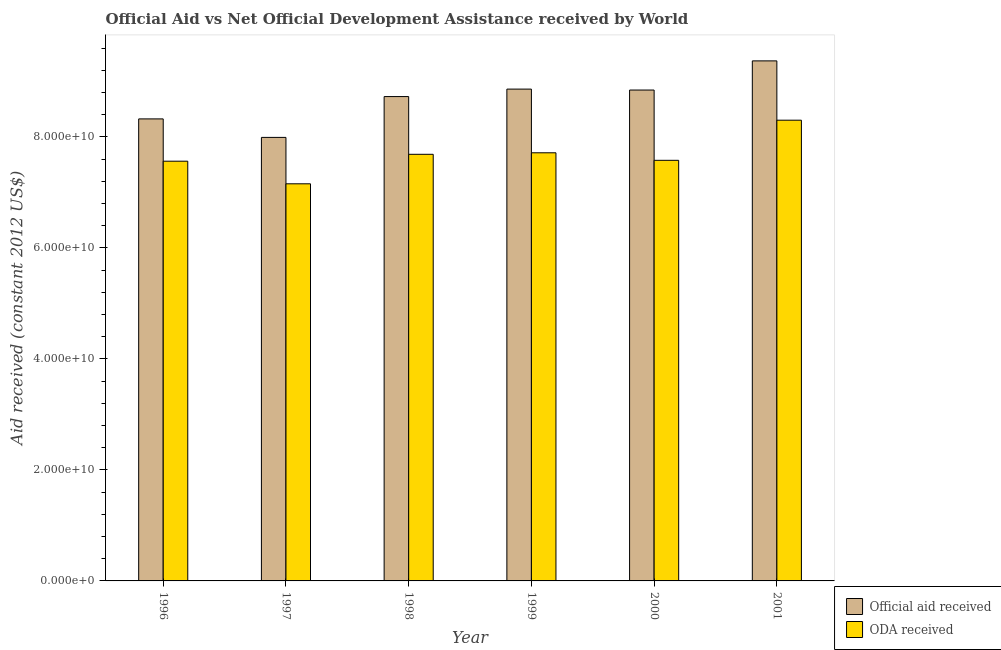How many different coloured bars are there?
Give a very brief answer. 2. Are the number of bars per tick equal to the number of legend labels?
Your answer should be very brief. Yes. How many bars are there on the 3rd tick from the left?
Provide a short and direct response. 2. What is the label of the 2nd group of bars from the left?
Offer a very short reply. 1997. What is the oda received in 1999?
Keep it short and to the point. 7.71e+1. Across all years, what is the maximum official aid received?
Ensure brevity in your answer.  9.37e+1. Across all years, what is the minimum official aid received?
Offer a terse response. 7.99e+1. In which year was the official aid received maximum?
Give a very brief answer. 2001. What is the total official aid received in the graph?
Your response must be concise. 5.21e+11. What is the difference between the official aid received in 1997 and that in 1999?
Offer a very short reply. -8.70e+09. What is the difference between the oda received in 1997 and the official aid received in 1996?
Your response must be concise. -4.07e+09. What is the average oda received per year?
Your answer should be very brief. 7.67e+1. What is the ratio of the official aid received in 1998 to that in 2000?
Provide a short and direct response. 0.99. Is the difference between the oda received in 1998 and 1999 greater than the difference between the official aid received in 1998 and 1999?
Ensure brevity in your answer.  No. What is the difference between the highest and the second highest oda received?
Your answer should be very brief. 5.87e+09. What is the difference between the highest and the lowest oda received?
Offer a very short reply. 1.15e+1. In how many years, is the official aid received greater than the average official aid received taken over all years?
Make the answer very short. 4. What does the 2nd bar from the left in 2000 represents?
Your answer should be compact. ODA received. What does the 2nd bar from the right in 2000 represents?
Your answer should be compact. Official aid received. What is the difference between two consecutive major ticks on the Y-axis?
Give a very brief answer. 2.00e+1. Does the graph contain any zero values?
Give a very brief answer. No. Does the graph contain grids?
Offer a terse response. No. How are the legend labels stacked?
Ensure brevity in your answer.  Vertical. What is the title of the graph?
Your answer should be very brief. Official Aid vs Net Official Development Assistance received by World . What is the label or title of the X-axis?
Your response must be concise. Year. What is the label or title of the Y-axis?
Your answer should be very brief. Aid received (constant 2012 US$). What is the Aid received (constant 2012 US$) in Official aid received in 1996?
Provide a succinct answer. 8.32e+1. What is the Aid received (constant 2012 US$) in ODA received in 1996?
Your answer should be compact. 7.56e+1. What is the Aid received (constant 2012 US$) of Official aid received in 1997?
Offer a very short reply. 7.99e+1. What is the Aid received (constant 2012 US$) in ODA received in 1997?
Your answer should be very brief. 7.15e+1. What is the Aid received (constant 2012 US$) in Official aid received in 1998?
Give a very brief answer. 8.73e+1. What is the Aid received (constant 2012 US$) of ODA received in 1998?
Ensure brevity in your answer.  7.69e+1. What is the Aid received (constant 2012 US$) in Official aid received in 1999?
Offer a very short reply. 8.86e+1. What is the Aid received (constant 2012 US$) in ODA received in 1999?
Your answer should be very brief. 7.71e+1. What is the Aid received (constant 2012 US$) in Official aid received in 2000?
Give a very brief answer. 8.84e+1. What is the Aid received (constant 2012 US$) of ODA received in 2000?
Keep it short and to the point. 7.58e+1. What is the Aid received (constant 2012 US$) in Official aid received in 2001?
Your answer should be compact. 9.37e+1. What is the Aid received (constant 2012 US$) of ODA received in 2001?
Your answer should be very brief. 8.30e+1. Across all years, what is the maximum Aid received (constant 2012 US$) of Official aid received?
Give a very brief answer. 9.37e+1. Across all years, what is the maximum Aid received (constant 2012 US$) of ODA received?
Keep it short and to the point. 8.30e+1. Across all years, what is the minimum Aid received (constant 2012 US$) of Official aid received?
Offer a terse response. 7.99e+1. Across all years, what is the minimum Aid received (constant 2012 US$) in ODA received?
Offer a very short reply. 7.15e+1. What is the total Aid received (constant 2012 US$) of Official aid received in the graph?
Provide a succinct answer. 5.21e+11. What is the total Aid received (constant 2012 US$) in ODA received in the graph?
Ensure brevity in your answer.  4.60e+11. What is the difference between the Aid received (constant 2012 US$) of Official aid received in 1996 and that in 1997?
Ensure brevity in your answer.  3.33e+09. What is the difference between the Aid received (constant 2012 US$) in ODA received in 1996 and that in 1997?
Make the answer very short. 4.07e+09. What is the difference between the Aid received (constant 2012 US$) of Official aid received in 1996 and that in 1998?
Your answer should be compact. -4.02e+09. What is the difference between the Aid received (constant 2012 US$) of ODA received in 1996 and that in 1998?
Your answer should be compact. -1.24e+09. What is the difference between the Aid received (constant 2012 US$) of Official aid received in 1996 and that in 1999?
Your response must be concise. -5.37e+09. What is the difference between the Aid received (constant 2012 US$) in ODA received in 1996 and that in 1999?
Provide a short and direct response. -1.51e+09. What is the difference between the Aid received (constant 2012 US$) in Official aid received in 1996 and that in 2000?
Keep it short and to the point. -5.20e+09. What is the difference between the Aid received (constant 2012 US$) of ODA received in 1996 and that in 2000?
Offer a very short reply. -1.57e+08. What is the difference between the Aid received (constant 2012 US$) in Official aid received in 1996 and that in 2001?
Make the answer very short. -1.05e+1. What is the difference between the Aid received (constant 2012 US$) in ODA received in 1996 and that in 2001?
Give a very brief answer. -7.39e+09. What is the difference between the Aid received (constant 2012 US$) in Official aid received in 1997 and that in 1998?
Make the answer very short. -7.35e+09. What is the difference between the Aid received (constant 2012 US$) of ODA received in 1997 and that in 1998?
Give a very brief answer. -5.31e+09. What is the difference between the Aid received (constant 2012 US$) in Official aid received in 1997 and that in 1999?
Your answer should be very brief. -8.70e+09. What is the difference between the Aid received (constant 2012 US$) of ODA received in 1997 and that in 1999?
Your answer should be very brief. -5.59e+09. What is the difference between the Aid received (constant 2012 US$) of Official aid received in 1997 and that in 2000?
Keep it short and to the point. -8.53e+09. What is the difference between the Aid received (constant 2012 US$) in ODA received in 1997 and that in 2000?
Offer a very short reply. -4.23e+09. What is the difference between the Aid received (constant 2012 US$) in Official aid received in 1997 and that in 2001?
Offer a terse response. -1.38e+1. What is the difference between the Aid received (constant 2012 US$) in ODA received in 1997 and that in 2001?
Keep it short and to the point. -1.15e+1. What is the difference between the Aid received (constant 2012 US$) of Official aid received in 1998 and that in 1999?
Give a very brief answer. -1.35e+09. What is the difference between the Aid received (constant 2012 US$) in ODA received in 1998 and that in 1999?
Your answer should be very brief. -2.73e+08. What is the difference between the Aid received (constant 2012 US$) of Official aid received in 1998 and that in 2000?
Provide a short and direct response. -1.18e+09. What is the difference between the Aid received (constant 2012 US$) in ODA received in 1998 and that in 2000?
Your answer should be compact. 1.08e+09. What is the difference between the Aid received (constant 2012 US$) in Official aid received in 1998 and that in 2001?
Your answer should be compact. -6.43e+09. What is the difference between the Aid received (constant 2012 US$) in ODA received in 1998 and that in 2001?
Make the answer very short. -6.15e+09. What is the difference between the Aid received (constant 2012 US$) in Official aid received in 1999 and that in 2000?
Your answer should be very brief. 1.71e+08. What is the difference between the Aid received (constant 2012 US$) in ODA received in 1999 and that in 2000?
Offer a terse response. 1.36e+09. What is the difference between the Aid received (constant 2012 US$) of Official aid received in 1999 and that in 2001?
Your answer should be compact. -5.08e+09. What is the difference between the Aid received (constant 2012 US$) of ODA received in 1999 and that in 2001?
Ensure brevity in your answer.  -5.87e+09. What is the difference between the Aid received (constant 2012 US$) in Official aid received in 2000 and that in 2001?
Offer a very short reply. -5.25e+09. What is the difference between the Aid received (constant 2012 US$) in ODA received in 2000 and that in 2001?
Provide a succinct answer. -7.23e+09. What is the difference between the Aid received (constant 2012 US$) of Official aid received in 1996 and the Aid received (constant 2012 US$) of ODA received in 1997?
Your answer should be very brief. 1.17e+1. What is the difference between the Aid received (constant 2012 US$) in Official aid received in 1996 and the Aid received (constant 2012 US$) in ODA received in 1998?
Provide a succinct answer. 6.38e+09. What is the difference between the Aid received (constant 2012 US$) in Official aid received in 1996 and the Aid received (constant 2012 US$) in ODA received in 1999?
Ensure brevity in your answer.  6.11e+09. What is the difference between the Aid received (constant 2012 US$) of Official aid received in 1996 and the Aid received (constant 2012 US$) of ODA received in 2000?
Keep it short and to the point. 7.46e+09. What is the difference between the Aid received (constant 2012 US$) in Official aid received in 1996 and the Aid received (constant 2012 US$) in ODA received in 2001?
Your answer should be compact. 2.32e+08. What is the difference between the Aid received (constant 2012 US$) in Official aid received in 1997 and the Aid received (constant 2012 US$) in ODA received in 1998?
Make the answer very short. 3.05e+09. What is the difference between the Aid received (constant 2012 US$) in Official aid received in 1997 and the Aid received (constant 2012 US$) in ODA received in 1999?
Your answer should be very brief. 2.77e+09. What is the difference between the Aid received (constant 2012 US$) of Official aid received in 1997 and the Aid received (constant 2012 US$) of ODA received in 2000?
Offer a terse response. 4.13e+09. What is the difference between the Aid received (constant 2012 US$) in Official aid received in 1997 and the Aid received (constant 2012 US$) in ODA received in 2001?
Keep it short and to the point. -3.10e+09. What is the difference between the Aid received (constant 2012 US$) in Official aid received in 1998 and the Aid received (constant 2012 US$) in ODA received in 1999?
Provide a short and direct response. 1.01e+1. What is the difference between the Aid received (constant 2012 US$) in Official aid received in 1998 and the Aid received (constant 2012 US$) in ODA received in 2000?
Your response must be concise. 1.15e+1. What is the difference between the Aid received (constant 2012 US$) in Official aid received in 1998 and the Aid received (constant 2012 US$) in ODA received in 2001?
Your response must be concise. 4.26e+09. What is the difference between the Aid received (constant 2012 US$) of Official aid received in 1999 and the Aid received (constant 2012 US$) of ODA received in 2000?
Provide a succinct answer. 1.28e+1. What is the difference between the Aid received (constant 2012 US$) in Official aid received in 1999 and the Aid received (constant 2012 US$) in ODA received in 2001?
Your answer should be very brief. 5.60e+09. What is the difference between the Aid received (constant 2012 US$) of Official aid received in 2000 and the Aid received (constant 2012 US$) of ODA received in 2001?
Offer a terse response. 5.43e+09. What is the average Aid received (constant 2012 US$) of Official aid received per year?
Provide a succinct answer. 8.69e+1. What is the average Aid received (constant 2012 US$) of ODA received per year?
Provide a short and direct response. 7.67e+1. In the year 1996, what is the difference between the Aid received (constant 2012 US$) in Official aid received and Aid received (constant 2012 US$) in ODA received?
Provide a succinct answer. 7.62e+09. In the year 1997, what is the difference between the Aid received (constant 2012 US$) in Official aid received and Aid received (constant 2012 US$) in ODA received?
Give a very brief answer. 8.36e+09. In the year 1998, what is the difference between the Aid received (constant 2012 US$) in Official aid received and Aid received (constant 2012 US$) in ODA received?
Make the answer very short. 1.04e+1. In the year 1999, what is the difference between the Aid received (constant 2012 US$) of Official aid received and Aid received (constant 2012 US$) of ODA received?
Provide a succinct answer. 1.15e+1. In the year 2000, what is the difference between the Aid received (constant 2012 US$) of Official aid received and Aid received (constant 2012 US$) of ODA received?
Give a very brief answer. 1.27e+1. In the year 2001, what is the difference between the Aid received (constant 2012 US$) of Official aid received and Aid received (constant 2012 US$) of ODA received?
Make the answer very short. 1.07e+1. What is the ratio of the Aid received (constant 2012 US$) in Official aid received in 1996 to that in 1997?
Your answer should be very brief. 1.04. What is the ratio of the Aid received (constant 2012 US$) in ODA received in 1996 to that in 1997?
Ensure brevity in your answer.  1.06. What is the ratio of the Aid received (constant 2012 US$) in Official aid received in 1996 to that in 1998?
Your answer should be very brief. 0.95. What is the ratio of the Aid received (constant 2012 US$) in ODA received in 1996 to that in 1998?
Make the answer very short. 0.98. What is the ratio of the Aid received (constant 2012 US$) in Official aid received in 1996 to that in 1999?
Make the answer very short. 0.94. What is the ratio of the Aid received (constant 2012 US$) of ODA received in 1996 to that in 1999?
Your response must be concise. 0.98. What is the ratio of the Aid received (constant 2012 US$) in Official aid received in 1996 to that in 2001?
Offer a terse response. 0.89. What is the ratio of the Aid received (constant 2012 US$) in ODA received in 1996 to that in 2001?
Provide a succinct answer. 0.91. What is the ratio of the Aid received (constant 2012 US$) of Official aid received in 1997 to that in 1998?
Your answer should be very brief. 0.92. What is the ratio of the Aid received (constant 2012 US$) of ODA received in 1997 to that in 1998?
Offer a very short reply. 0.93. What is the ratio of the Aid received (constant 2012 US$) of Official aid received in 1997 to that in 1999?
Provide a succinct answer. 0.9. What is the ratio of the Aid received (constant 2012 US$) of ODA received in 1997 to that in 1999?
Keep it short and to the point. 0.93. What is the ratio of the Aid received (constant 2012 US$) of Official aid received in 1997 to that in 2000?
Your response must be concise. 0.9. What is the ratio of the Aid received (constant 2012 US$) of ODA received in 1997 to that in 2000?
Your response must be concise. 0.94. What is the ratio of the Aid received (constant 2012 US$) in Official aid received in 1997 to that in 2001?
Make the answer very short. 0.85. What is the ratio of the Aid received (constant 2012 US$) of ODA received in 1997 to that in 2001?
Make the answer very short. 0.86. What is the ratio of the Aid received (constant 2012 US$) of ODA received in 1998 to that in 1999?
Give a very brief answer. 1. What is the ratio of the Aid received (constant 2012 US$) in Official aid received in 1998 to that in 2000?
Offer a very short reply. 0.99. What is the ratio of the Aid received (constant 2012 US$) of ODA received in 1998 to that in 2000?
Keep it short and to the point. 1.01. What is the ratio of the Aid received (constant 2012 US$) of Official aid received in 1998 to that in 2001?
Give a very brief answer. 0.93. What is the ratio of the Aid received (constant 2012 US$) in ODA received in 1998 to that in 2001?
Make the answer very short. 0.93. What is the ratio of the Aid received (constant 2012 US$) in Official aid received in 1999 to that in 2000?
Keep it short and to the point. 1. What is the ratio of the Aid received (constant 2012 US$) of ODA received in 1999 to that in 2000?
Make the answer very short. 1.02. What is the ratio of the Aid received (constant 2012 US$) of Official aid received in 1999 to that in 2001?
Make the answer very short. 0.95. What is the ratio of the Aid received (constant 2012 US$) in ODA received in 1999 to that in 2001?
Make the answer very short. 0.93. What is the ratio of the Aid received (constant 2012 US$) in Official aid received in 2000 to that in 2001?
Ensure brevity in your answer.  0.94. What is the ratio of the Aid received (constant 2012 US$) of ODA received in 2000 to that in 2001?
Your response must be concise. 0.91. What is the difference between the highest and the second highest Aid received (constant 2012 US$) of Official aid received?
Make the answer very short. 5.08e+09. What is the difference between the highest and the second highest Aid received (constant 2012 US$) of ODA received?
Keep it short and to the point. 5.87e+09. What is the difference between the highest and the lowest Aid received (constant 2012 US$) in Official aid received?
Your answer should be very brief. 1.38e+1. What is the difference between the highest and the lowest Aid received (constant 2012 US$) of ODA received?
Your answer should be very brief. 1.15e+1. 